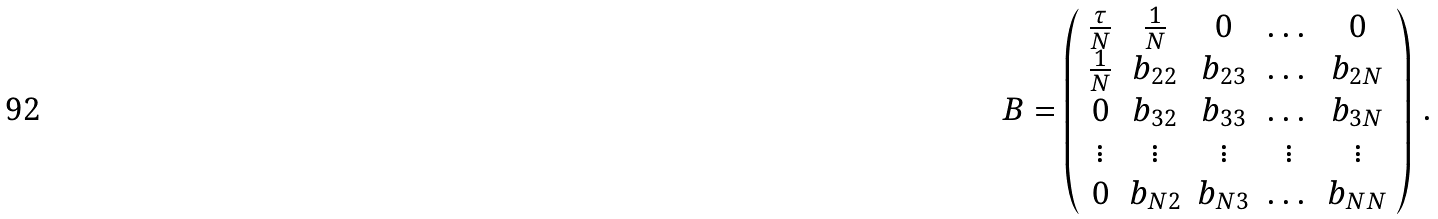<formula> <loc_0><loc_0><loc_500><loc_500>B = \left ( \begin{array} { c c c c c } \frac { \tau } { N } & \frac { 1 } { N } & 0 & \dots & 0 \\ \frac { 1 } { N } & b _ { 2 2 } & b _ { 2 3 } & \dots & b _ { 2 N } \\ 0 & b _ { 3 2 } & b _ { 3 3 } & \dots & b _ { 3 N } \\ \vdots & \vdots & \vdots & \vdots & \vdots \\ 0 & b _ { N 2 } & b _ { N 3 } & \dots & b _ { N N } \end{array} \right ) \, .</formula> 